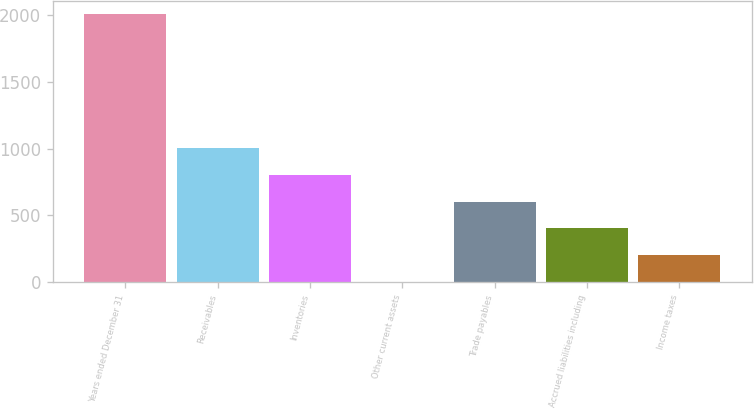Convert chart. <chart><loc_0><loc_0><loc_500><loc_500><bar_chart><fcel>Years ended December 31<fcel>Receivables<fcel>Inventories<fcel>Other current assets<fcel>Trade payables<fcel>Accrued liabilities including<fcel>Income taxes<nl><fcel>2007<fcel>1003.8<fcel>803.16<fcel>0.6<fcel>602.52<fcel>401.88<fcel>201.24<nl></chart> 